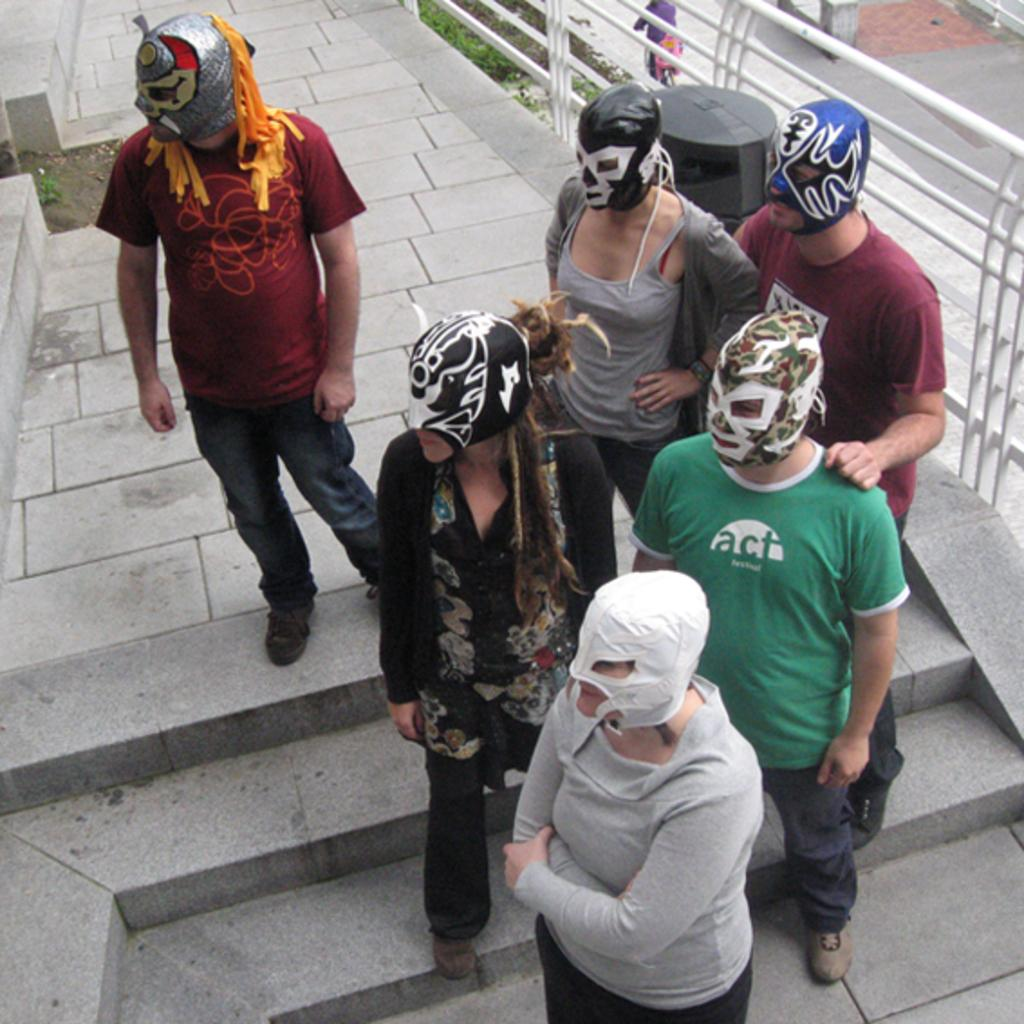How many people are in the image? There is a group of persons in the image, but the exact number is not specified. What are the persons wearing on their faces? The persons are wearing masks in the image. What can be seen in the background of the image? There is a ground visible in the background of the image. Where is the fencing located in the image? The fencing is on the top right side of the image. What type of board is the manager using to communicate with the team members in the image? There is no board or manager present in the image; it features a group of persons wearing masks. What color is the straw that the person in the image is holding? There is no straw present in the image. 